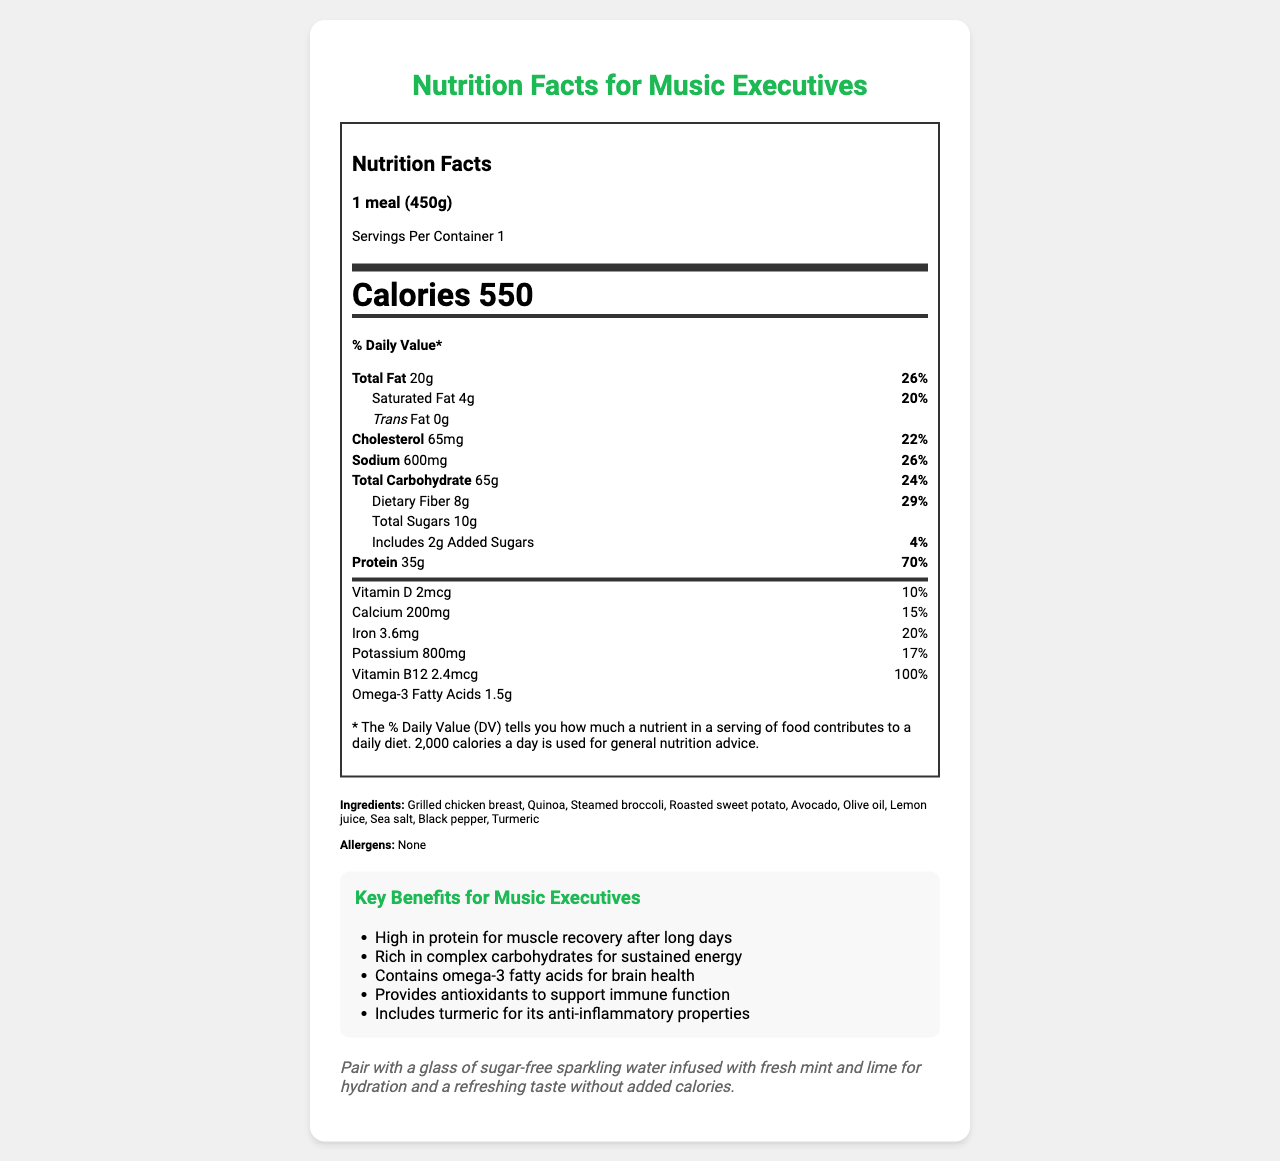what is the serving size? The serving size is specified at the top of the nutrition facts label and indicated as "1 meal (450g)".
Answer: 1 meal (450g) how many calories are in one serving? The number of calories per serving is clearly stated in the nutrition facts section as "Calories 550".
Answer: 550 how much protein does one serving contain? The protein content per serving is shown under the nutrient section as "Protein 35g".
Answer: 35g what percentage of the daily value of dietary fiber does one serving provide? The daily value percentage for dietary fiber is indicated next to its amount: "Dietary Fiber 8g 29%".
Answer: 29% how much vitamin B12 is in one serving, and what percentage of the daily value does it represent? The vitamin B12 content is "2.4mcg" and it represents "100%" of the daily value.
Answer: 2.4mcg, 100% what are the main ingredients in this meal? The main ingredients are listed under the "Ingredients" section.
Answer: Grilled chicken breast, Quinoa, Steamed broccoli, Roasted sweet potato, Avocado, Olive oil, Lemon juice, Sea salt, Black pepper, Turmeric which benefit is specifically highlighted for brain health? The key benefit for brain health mentioned is "Contains omega-3 fatty acids for brain health".
Answer: Contains omega-3 fatty acids for brain health what is the recommended beverage pairing with this meal? The pairing recommendation is "Pair with a glass of sugar-free sparkling water infused with fresh mint and lime".
Answer: Sugar-free sparkling water infused with fresh mint and lime how much total fat does this meal contain? The total fat content is listed as "Total Fat 20g".
Answer: 20g what percentage of the daily value does sodium represent in this meal? The sodium content represents "26%" of the daily value.
Answer: 26% which of the following nutrients has the highest daily value percentage? (A) Total Fat (B) Protein (C) Dietary Fiber (D) Iron Protein has the highest daily value percentage at "70%", compared to Total Fat (26%), Dietary Fiber (29%), and Iron (20%).
Answer: B how many grams of added sugars are included in this meal? (1) 0g (2) 2g (3) 4g (4) 10g The amount of added sugars is specified as "Includes 2g Added Sugars".
Answer: 2 does this meal contain any allergens? The allergens section indicates "None".
Answer: No is this meal high in calories? The meal contains 550 calories, which can be considered high for a single meal.
Answer: Yes summarize the nutrition and health benefits of this meal for a busy music executive. The meal offers a comprehensive blend of nutrients geared towards maintaining energy and cognitive function. Lean protein helps with muscle recovery, while complex carbs and healthy fats ensure sustained energy. Omega-3s and vitamin B12 support brain health. The inclusion of ingredients with antioxidants and anti-inflammatory attributes further enhances its health benefits.
Answer: This meal provides a balanced combination of essential nutrients, including lean protein, complex carbohydrates, and healthy fats designed to support busy music executives. It is high in protein (35g) to aid muscle recovery, rich in dietary fiber (8g), and offers critical nutrients such as vitamin B12 and omega-3 fatty acids for brain health. The meal also boasts immunity-boosting antioxidants and anti-inflammatory properties from ingredients like turmeric. Paired with sugar-free sparkling water, it presents a nutritious option to maintain energy and focus throughout the day. what is the exact amount of vitamin A in this meal? The document does not provide any information regarding the amount of vitamin A.
Answer: Not enough information 